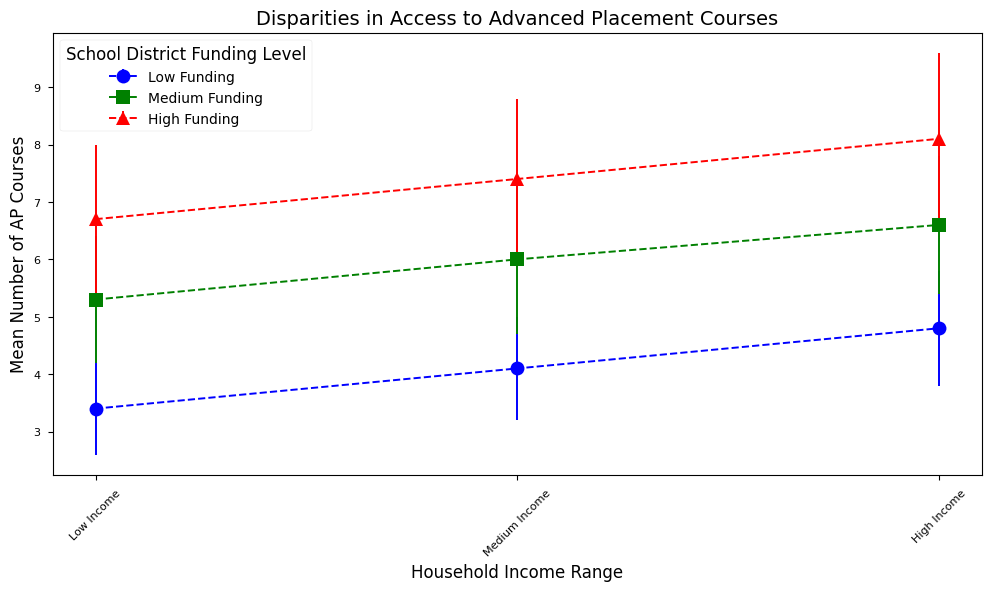What's the trend in the mean number of AP courses as household income increases for high school districts with high funding? Looking at the blue triangles, we see that the mean number of AP courses increases as household income rises from low to high. Specifically, it goes from approximately 6.7 for low-income, 7.4 for medium-income, and 8.1 for high-income households.
Answer: The number of AP courses increases Which household income group has the highest variability (standard deviation) in the mean number of AP courses in high funding districts? The group with the highest standard deviation in high funding districts has red triangles indicating the household income range. Among all the groups, high-income households show the highest standard deviation of 1.5.
Answer: High-income households What's the difference in the mean number of AP courses between low-income and high-income students in medium funding districts? For medium funding districts (green squares), the mean number of AP courses for low-income students is 5.3, and for high-income students, it is 6.6. The difference is 6.6 - 5.3, which equals 1.3.
Answer: 1.3 Compare the mean number of AP courses for high-income students in low funding districts versus high-income students in high funding districts. The mean number of AP courses for high-income students in low funding districts (blue circles) is 4.8, and for high-income students in high funding districts (red triangles), it is 8.1. 8.1 is greater than 4.8.
Answer: High funding districts have more courses What is the standard deviation for medium-income students in low funding districts and how does it compare to that for medium-income students in medium funding districts? For medium-income students in low funding districts (blue circles), the standard deviation is 0.9. For those in medium funding districts (green squares), it is 1.3. The standard deviation is higher for medium-income students in medium funding districts.
Answer: Medium funding districts have higher variability What is the overall trend in the mean number of AP courses as we go from low funding to high funding across income ranges? As we move from low funding (blue circles) to medium funding (green squares) to high funding (red triangles), the mean number of AP courses increases across all income ranges. For low-income, it increases from 3.4 to 5.3 to 6.7; for medium-income, from 4.1 to 6.0 to 7.4; and for high-income, from 4.8 to 6.6 to 8.1.
Answer: The number of AP courses increases For a medium-income group, how does the mean number of AP courses vary across different funding levels? For medium-income groups, the blue circles, green squares, and red triangles indicate low, medium, and high funding levels, respectively. The mean number of AP courses increases from 4.1 for low funding, to 6.0 for medium funding, and 7.4 for high funding.
Answer: The number of AP courses increases with funding level How does the variability in mean number of AP courses for low-income students change with the increase in school district funding? For low-income students, the standard deviation (variability) is 0.8 for low funding (blue circles), 1.1 for medium funding (green squares), and 1.3 for high funding (red triangles). Therefore, the variability increases with increasing school district funding.
Answer: Variability increases 